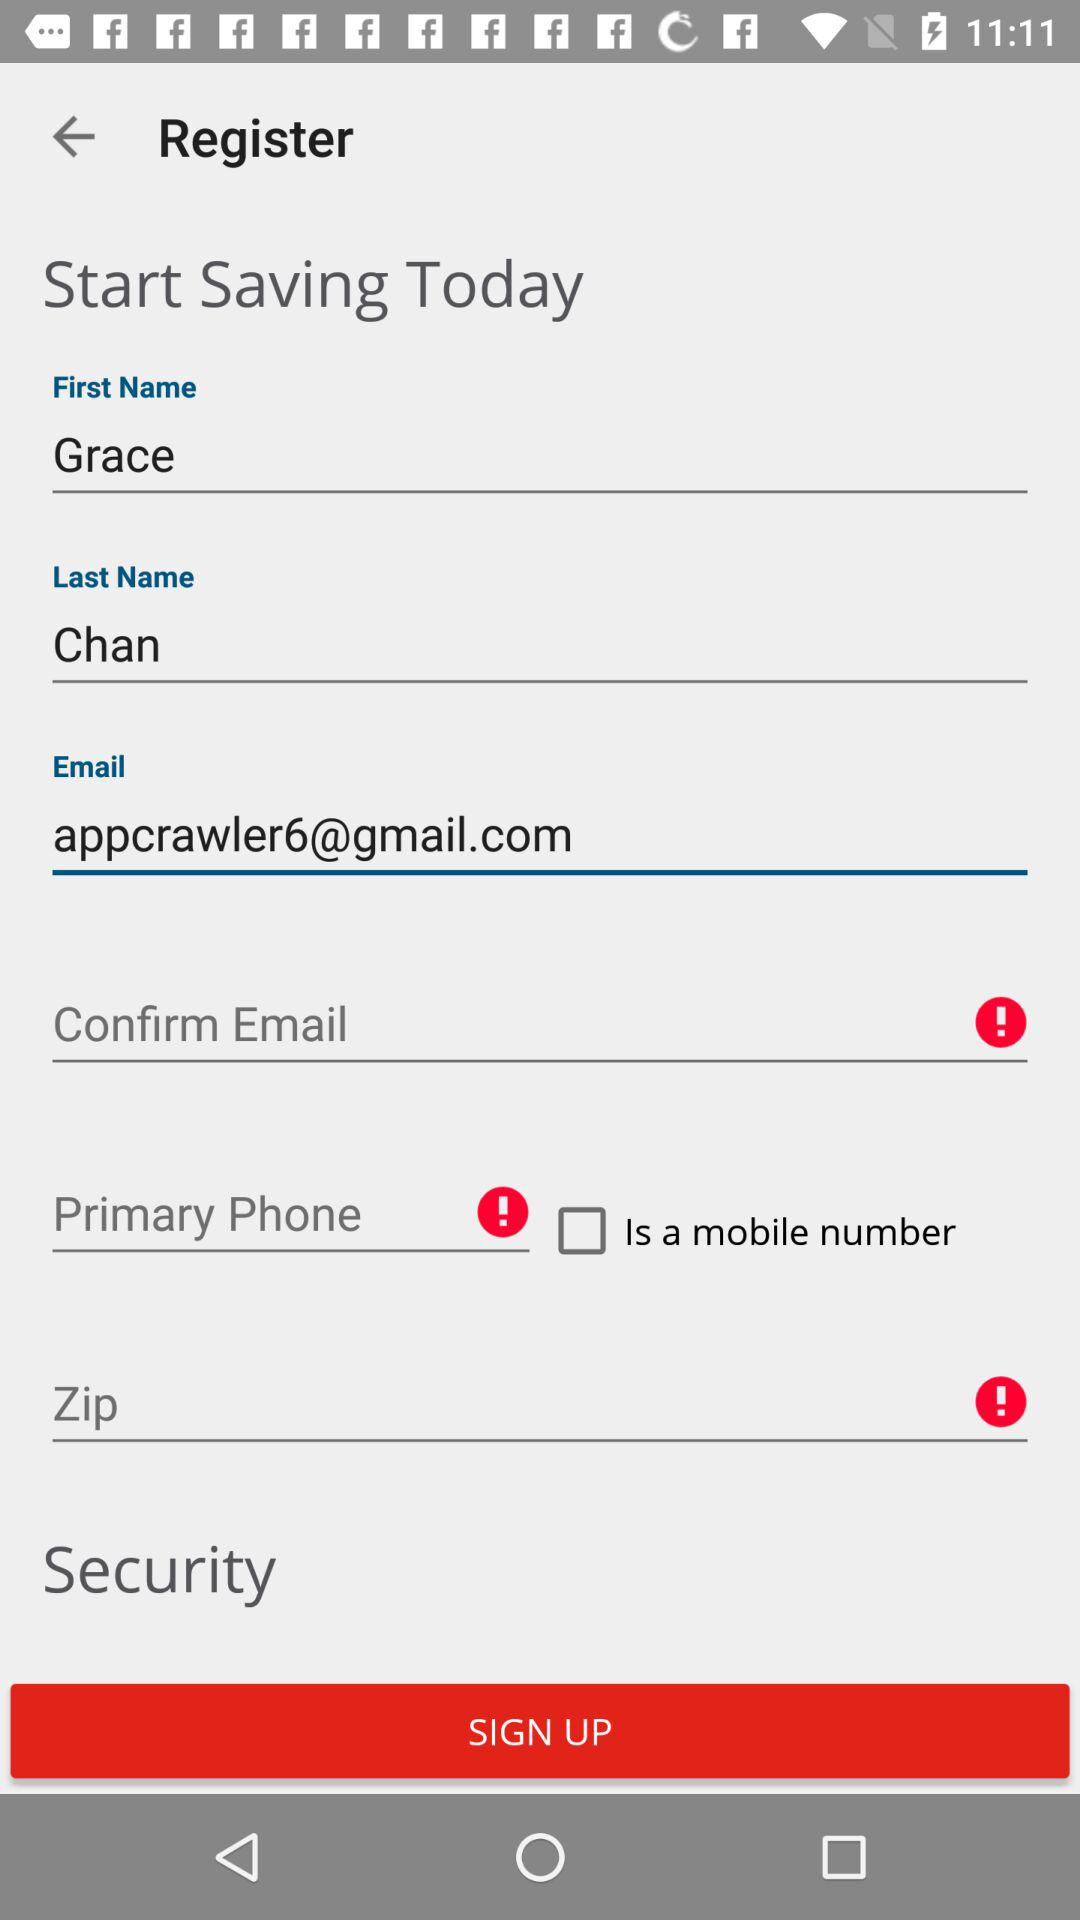What is the email address? The email address is appcrawler6@gmail.com. 